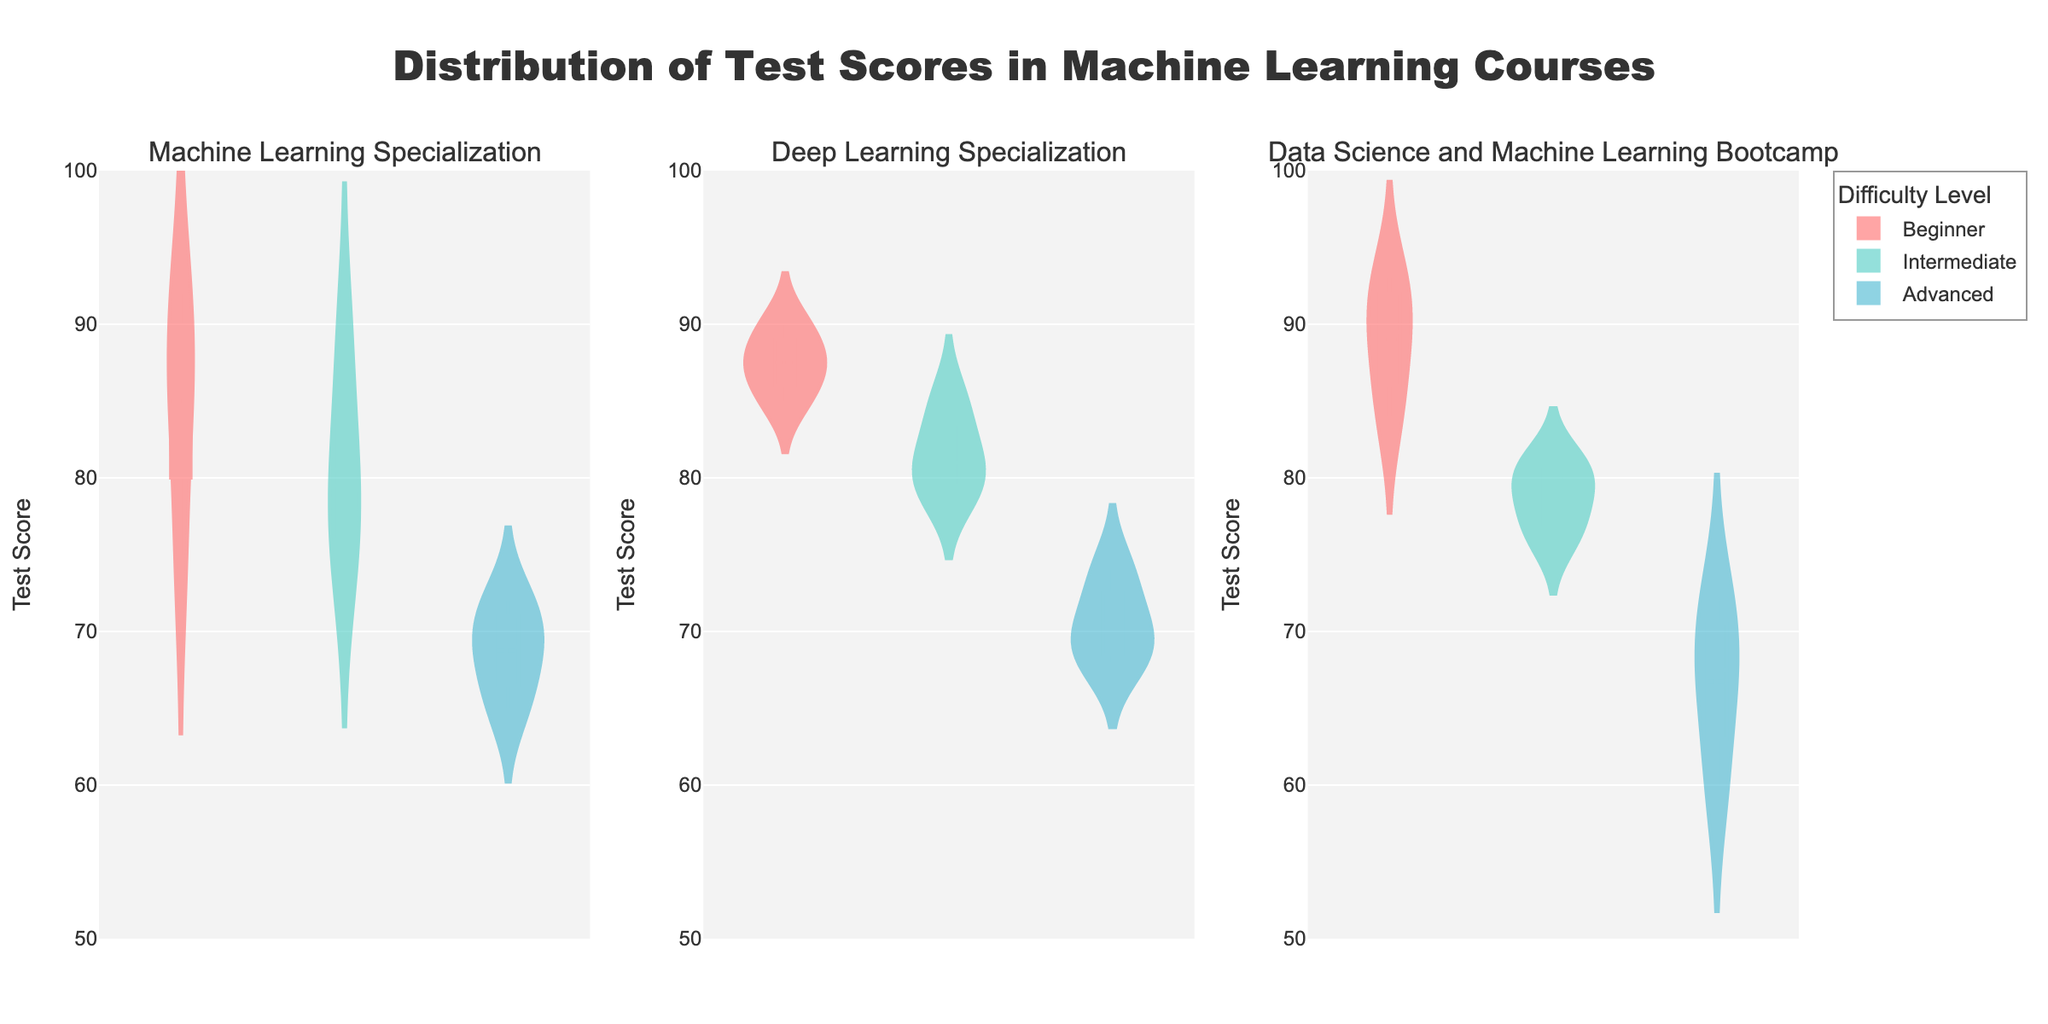What is the highest test score recorded in the Beginner difficulty for the Machine Learning Specialization course? To find the highest test score in a violin chart for Beginner difficulty in the Machine Learning Specialization subplot, look at the topmost point of the distribution for the Beginner category. This is indicated by the highest data point in that section.
Answer: 92 What is the range of test scores for the Intermediate difficulty in the Deep Learning Specialization course? The range of scores is determined by the difference between the highest and lowest scores in the Intermediate difficulty category of the Deep Learning Specialization subplot. Visualize the points from top to bottom within the Intermediate section.
Answer: 80–85 Which course has the lowest median test score for Advanced difficulty? The median score is marked by the horizontal line inside the violin. Compare the locations of these lines across all subplots for the Advanced difficulty category to find the lowest.
Answer: Data Science and Machine Learning Bootcamp How does the distribution of Beginner scores in the Machine Learning Specialization compare to those in the Data Science and Machine Learning Bootcamp? Compare the shapes, widths, and data point distributions of the violin plots for the Beginner difficulty in both Machine Learning Specialization and Data Science and Machine Learning Bootcamp. Look for differences in spread and central tendency.
Answer: Data Science and Machine Learning Bootcamp's scores are more spread out and have a higher central tendency What is the median score for Intermediate difficulty in the Machine Learning Specialization course? Locate the horizontal line within the Intermediate section of the violin chart for Machine Learning Specialization. This line is the median score.
Answer: 79.5 Are there any noticeable outliers in the Advanced difficulty for the Deep Learning Specialization course? Outliers can be identified as points that are significantly isolated from the general distribution of scores in the violin plot. Inspect the Advanced section of the Deep Learning Specialization violin plot for such points.
Answer: No Which difficulty level tends to have the widest distribution of scores across all courses? Observe the width of the violin plots across Beginner, Intermediate, and Advanced difficulty levels in all subplots. The widest distribution will show the most spread.
Answer: Advanced In the context of Beginner difficulty, which course has the most tightly clustered scores around the median? Compare the tightness around the median (horizontal line) within the Beginner sections of all subplots. A tighter clustering indicates less variability around the median score.
Answer: Deep Learning Specialization How do the mean scores for Intermediate difficulty compare between Deep Learning Specialization and Data Science and Machine Learning Bootcamp? The mean score is indicated by the marker (usually a diamond shape) within the violin plot. Compare these markers within the Intermediate sections of the Deep Learning Specialization and Data Science and Machine Learning Bootcamp subplots.
Answer: Deep Learning Specialization > Data Science and Machine Learning Bootcamp 